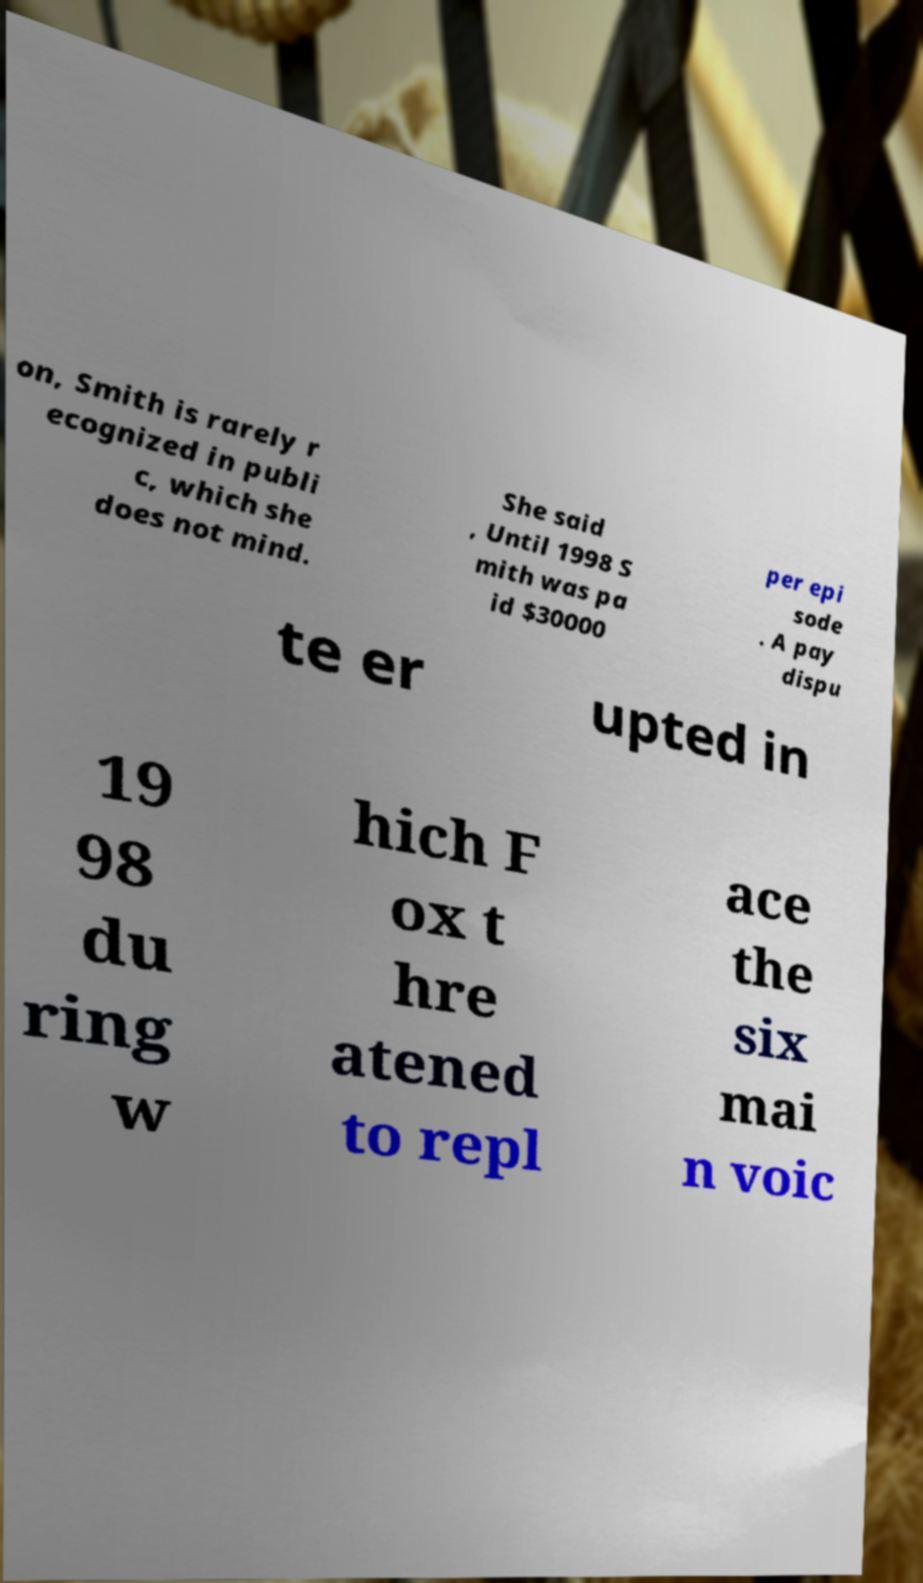Can you read and provide the text displayed in the image?This photo seems to have some interesting text. Can you extract and type it out for me? on, Smith is rarely r ecognized in publi c, which she does not mind. She said , Until 1998 S mith was pa id $30000 per epi sode . A pay dispu te er upted in 19 98 du ring w hich F ox t hre atened to repl ace the six mai n voic 